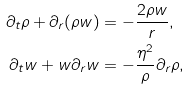<formula> <loc_0><loc_0><loc_500><loc_500>\partial _ { t } \rho + \partial _ { r } ( \rho w ) & = - \frac { 2 \rho w } { r } , \\ \partial _ { t } w + w \partial _ { r } w & = - \frac { \eta ^ { 2 } } { \rho } \partial _ { r } \rho ,</formula> 